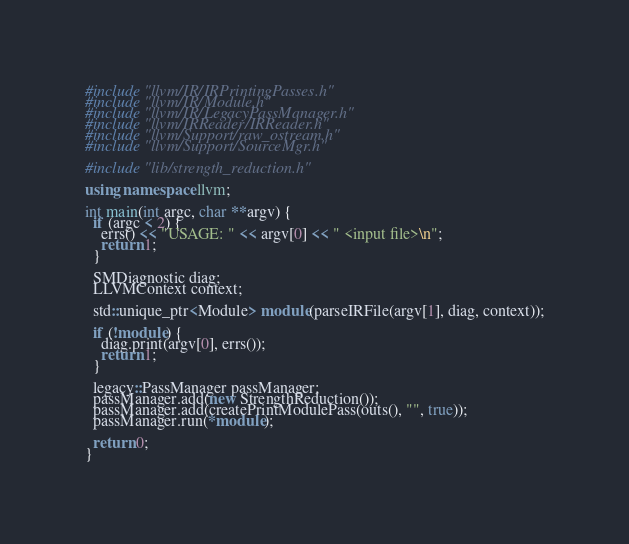<code> <loc_0><loc_0><loc_500><loc_500><_C++_>#include "llvm/IR/IRPrintingPasses.h"
#include "llvm/IR/Module.h"
#include "llvm/IR/LegacyPassManager.h"
#include "llvm/IRReader/IRReader.h"
#include "llvm/Support/raw_ostream.h"
#include "llvm/Support/SourceMgr.h"

#include "lib/strength_reduction.h"

using namespace llvm;

int main(int argc, char **argv) {
  if (argc < 2) {
    errs() << "USAGE: " << argv[0] << " <input file>\n";
    return 1;
  }

  SMDiagnostic diag;
  LLVMContext context;

  std::unique_ptr<Module> module(parseIRFile(argv[1], diag, context));

  if (!module) {
    diag.print(argv[0], errs());
    return 1;
  }

  legacy::PassManager passManager;
  passManager.add(new StrengthReduction());
  passManager.add(createPrintModulePass(outs(), "", true));
  passManager.run(*module);

  return 0;
}
</code> 